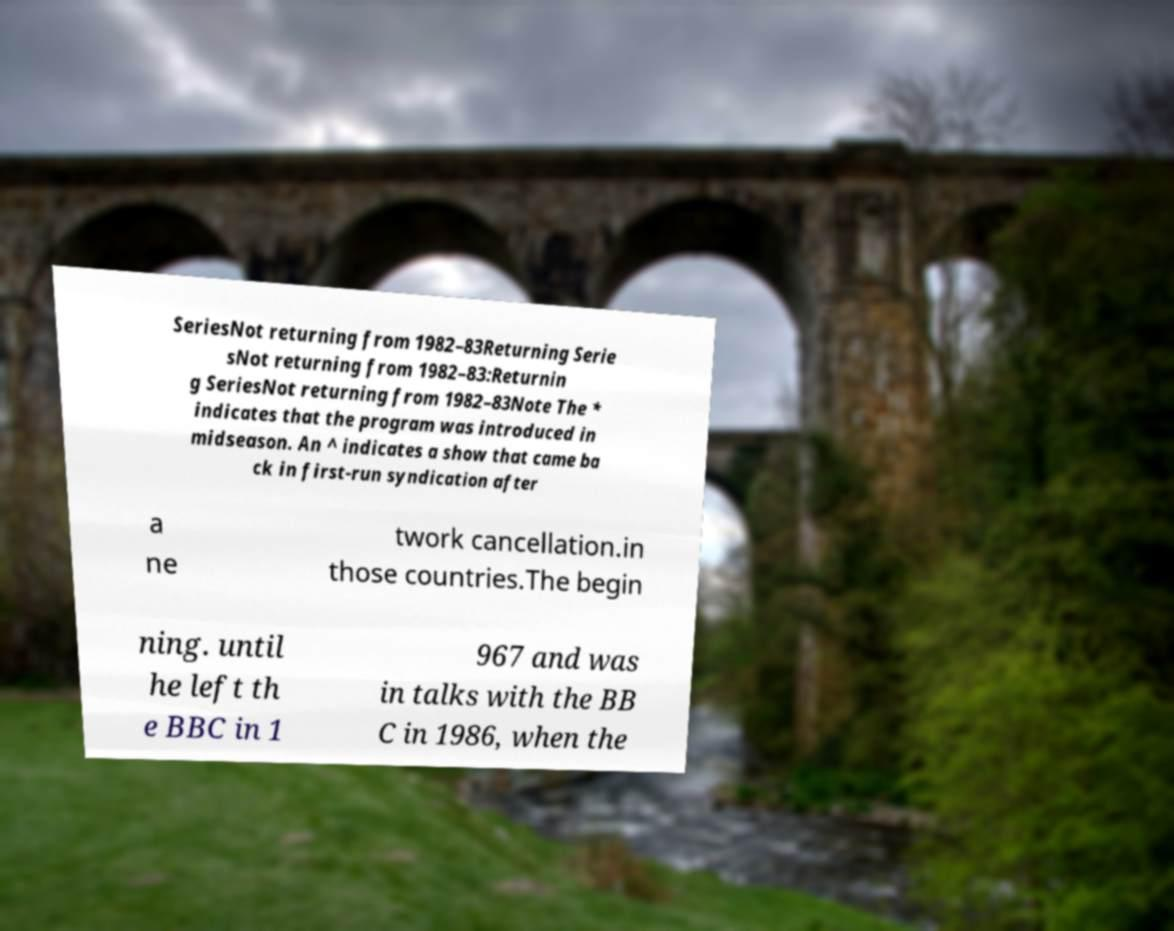Please identify and transcribe the text found in this image. SeriesNot returning from 1982–83Returning Serie sNot returning from 1982–83:Returnin g SeriesNot returning from 1982–83Note The * indicates that the program was introduced in midseason. An ^ indicates a show that came ba ck in first-run syndication after a ne twork cancellation.in those countries.The begin ning. until he left th e BBC in 1 967 and was in talks with the BB C in 1986, when the 